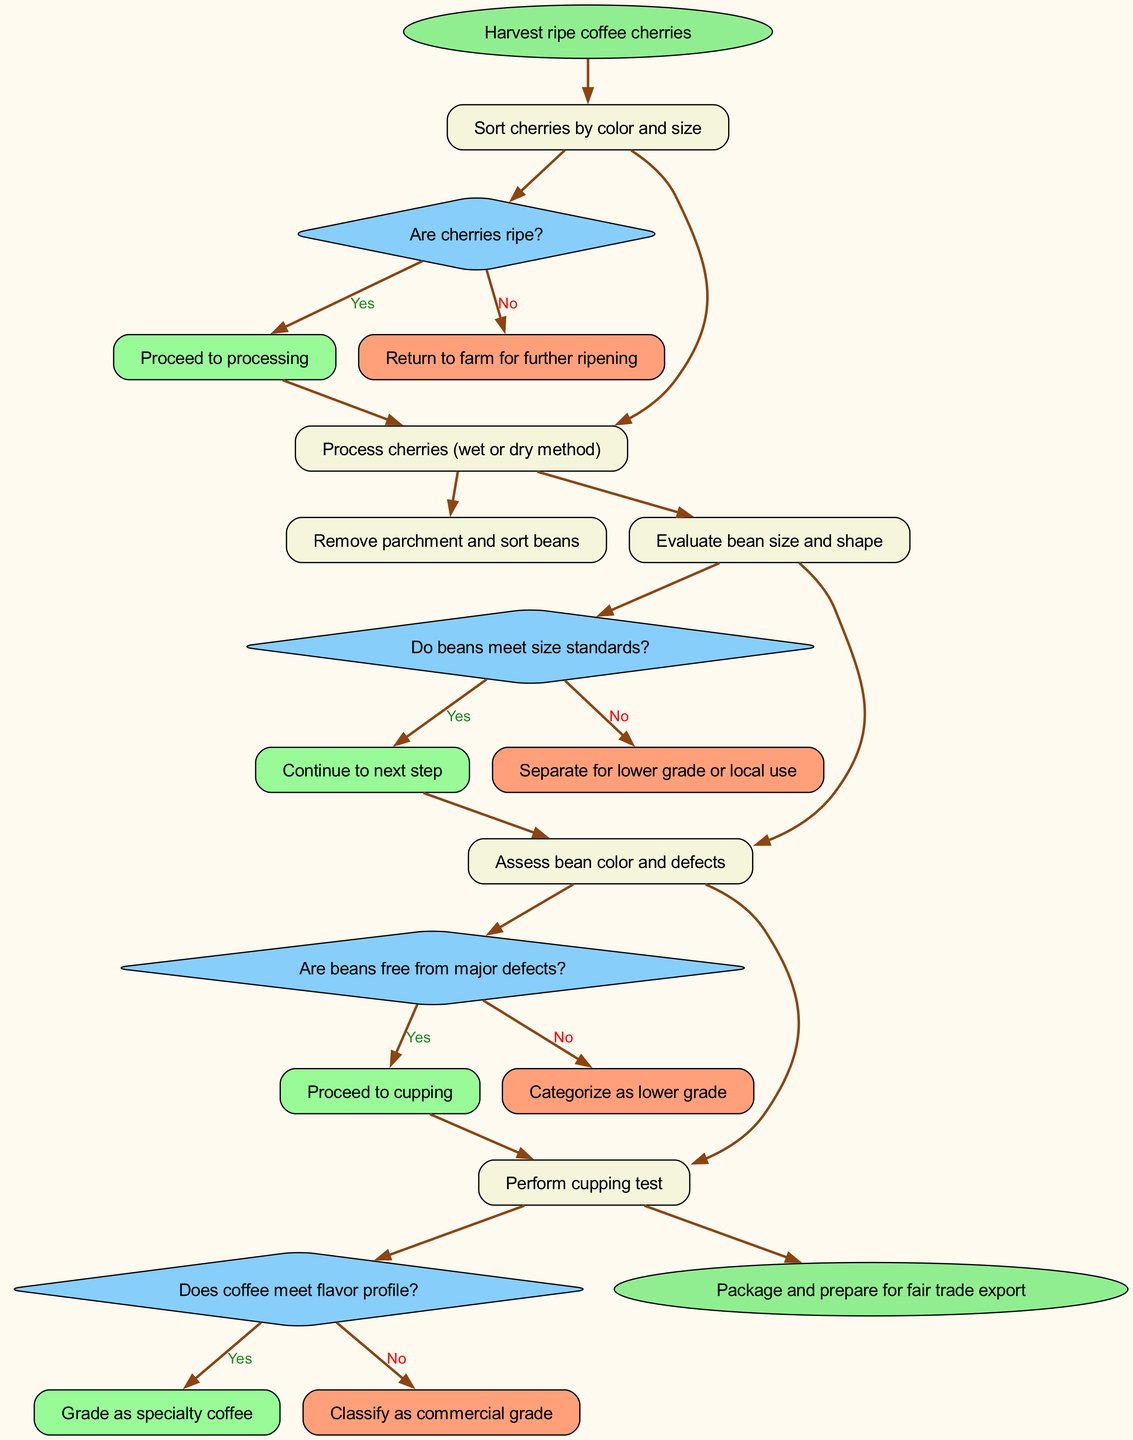What is the starting point of the process? The diagram begins with the node labeled "Harvest ripe coffee cherries," indicating the initial action in the coffee grading and sorting procedure.
Answer: Harvest ripe coffee cherries How many steps are in the processing sequence? There are five steps in the processing sequence, each detailing a specific action and decision related to coffee grading and sorting.
Answer: 5 What happens if the cherries are not ripe? If the cherries are not ripe, the process directs to "Return to farm for further ripening," which is an option outlined in the first decision node.
Answer: Return to farm for further ripening In which step is the cupping test performed? The cupping test is performed in the fifth step of the sequence, as indicated by the order of actions listed in the diagram.
Answer: Perform cupping test What is the consequence of beans not meeting size standards? If the beans do not meet size standards, they are separated for lower grade or local use, as stated in the decision after assessing bean size and shape.
Answer: Separate for lower grade or local use What is the final action before export? The final action before exporting the coffee is to "Package and prepare for fair trade export," marked as the end of the flow chart.
Answer: Package and prepare for fair trade export What must the coffee beans be free of to proceed to cupping? The beans must be free from major defects to proceed to the cupping test, as indicated by the decision node regarding bean color and defects.
Answer: Free from major defects What grade is assigned if the coffee meets the flavor profile? If the coffee meets the flavor profile in the cupping test, it is graded as specialty coffee, as specified in the last decision and outcome node.
Answer: Grade as specialty coffee 